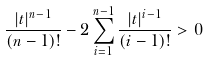Convert formula to latex. <formula><loc_0><loc_0><loc_500><loc_500>\frac { | t | ^ { n - 1 } } { ( n - 1 ) ! } - 2 \sum ^ { n - 1 } _ { i = 1 } \frac { | t | ^ { i - 1 } } { ( i - 1 ) ! } > 0</formula> 